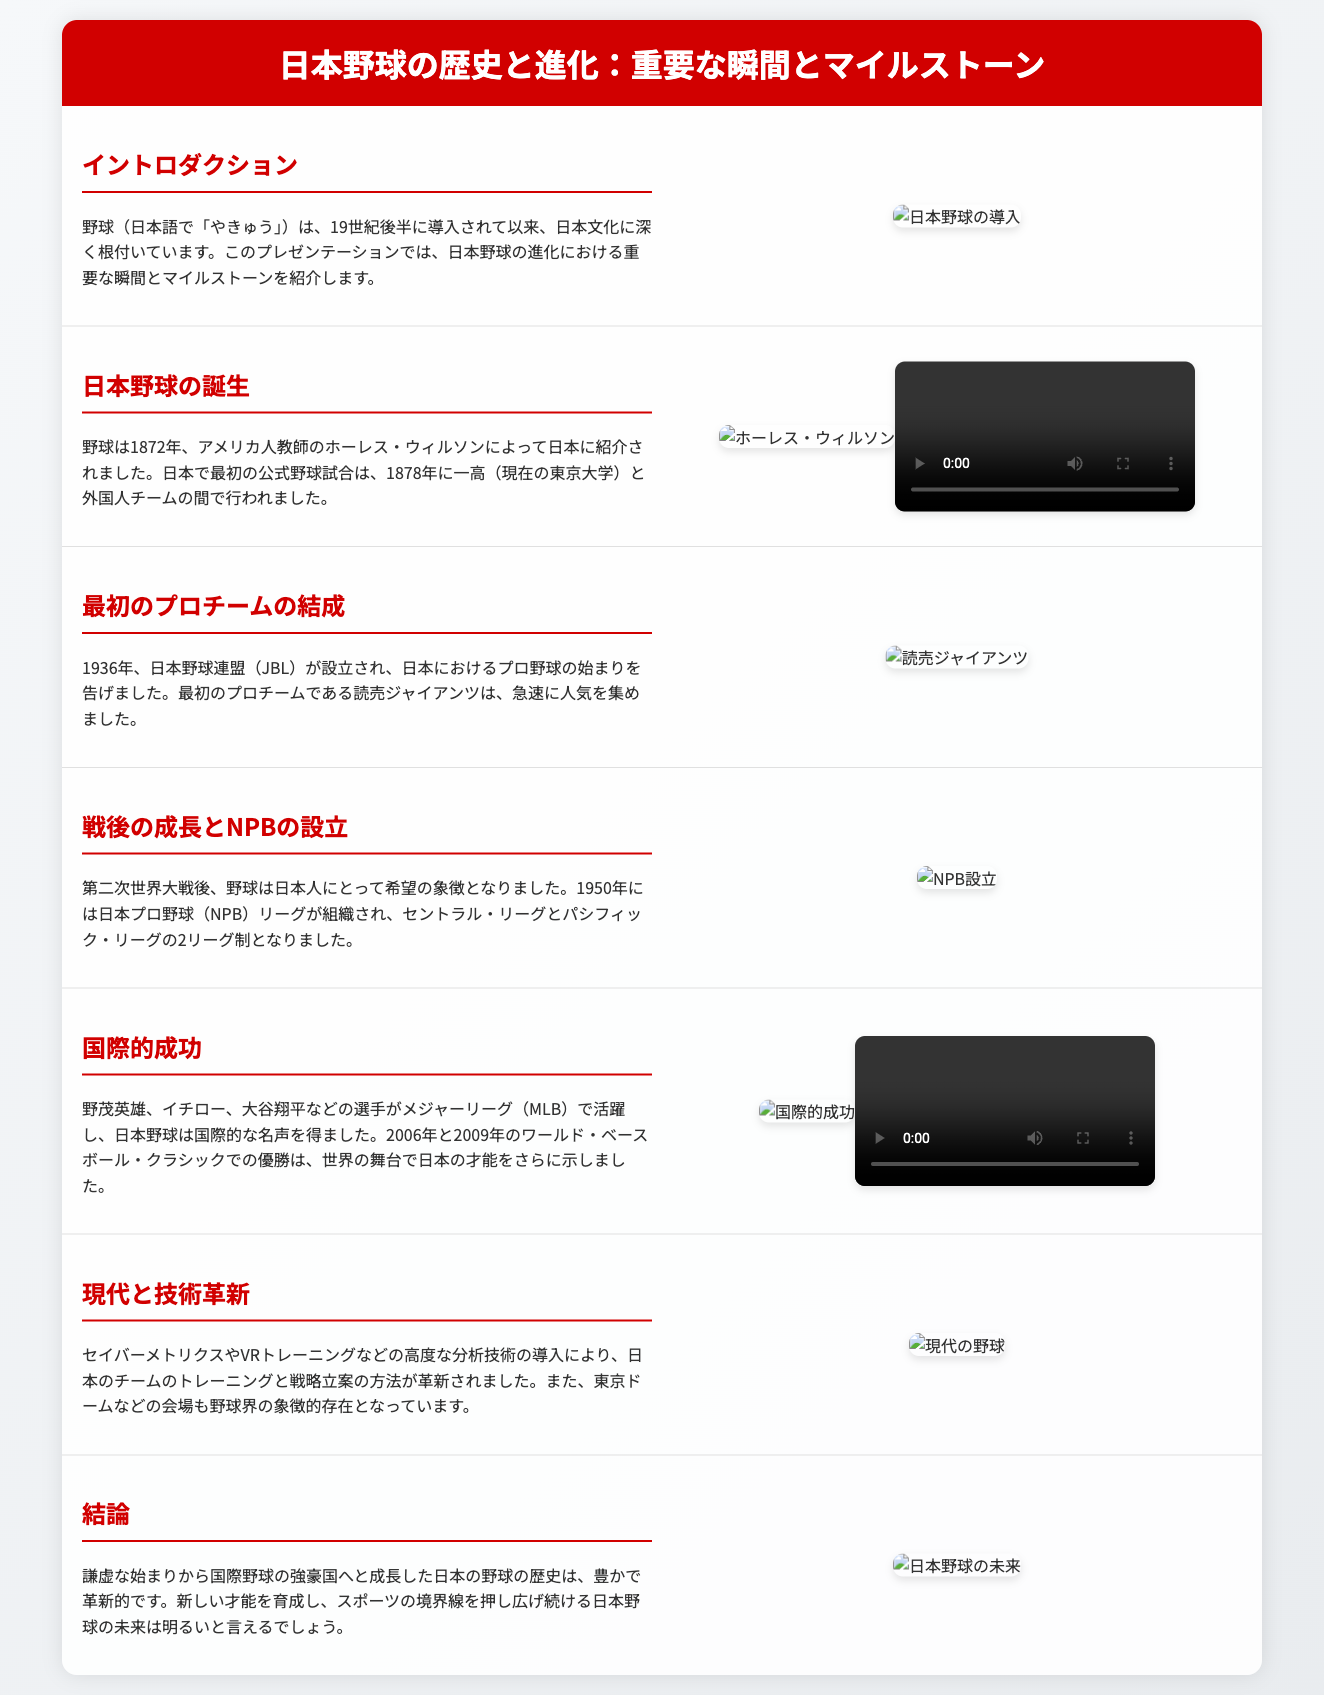What year was baseball introduced to Japan? Baseball was introduced to Japan in 1872, as mentioned in the section about its birth.
Answer: 1872 Who was the American teacher that introduced baseball to Japan? The document states that Horace Wilson introduced baseball to Japan.
Answer: ホーレス・ウィルソン What was the first official baseball game in Japan? The first official game mentioned was played between 一高 and a foreign team in 1878.
Answer: 一高と外国人チーム When was the Japan Professional Baseball (NPB) league organized? The document indicates that the NPB league was organized in 1950.
Answer: 1950 What team is recognized as the first professional team in Japan? The section about the first professional team states that ゆうものジャイアンツ is the first professional team in Japan.
Answer: 読売ジャイアンツ Which two leagues were formed in Japanese professional baseball? The document highlights the establishment of the セントラル・リーグ and パシフィック・リーグ.
Answer: セントラル・リーグとパシフィック・リーグ Who are some of the notable players mentioned that found success in Major League Baseball? The section on international success names 野茂英雄, イチロー, and 大谷翔平 as examples.
Answer: 野茂英雄、イチロー、大谷翔平 What technological advancements are mentioned that have impacted Japanese baseball? The document references セイバーメトリクス and VRトレーニング as technological advancements.
Answer: セイバーメトリクスやVRトレーニング What does the conclusion say about the future of Japanese baseball? The conclusion expresses optimism about the future growth and talent cultivation in Japanese baseball.
Answer: 明るい 